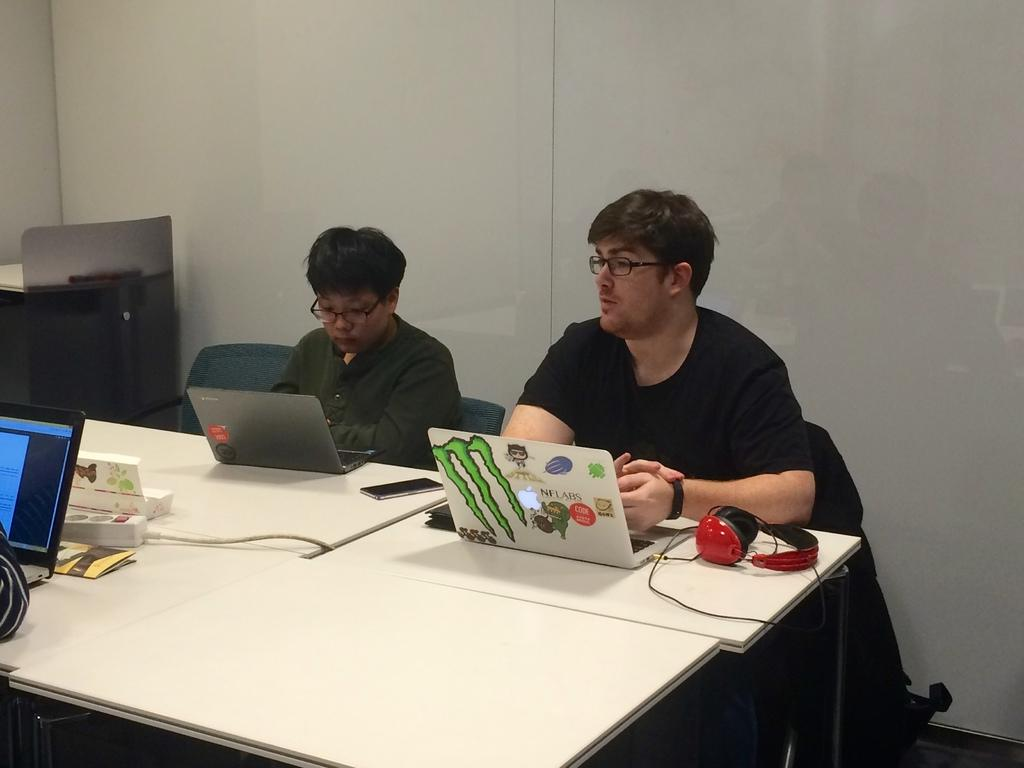How many people are in the image? There are two men in the image. What are the men doing in the image? The men are sitting in front of a table. What objects can be seen on the table? There is a laptop, cell phones, and headphones on the table. What can be observed about the men's appearance? Both men are wearing glasses. What is visible behind the men? There is a wall behind the men. What type of point is the servant making in the image? There is no servant present in the image, and no one is making a point. What type of carpentry work is being done in the image? There is no carpentry work being done in the image; the men are sitting in front of a table with electronic devices. 